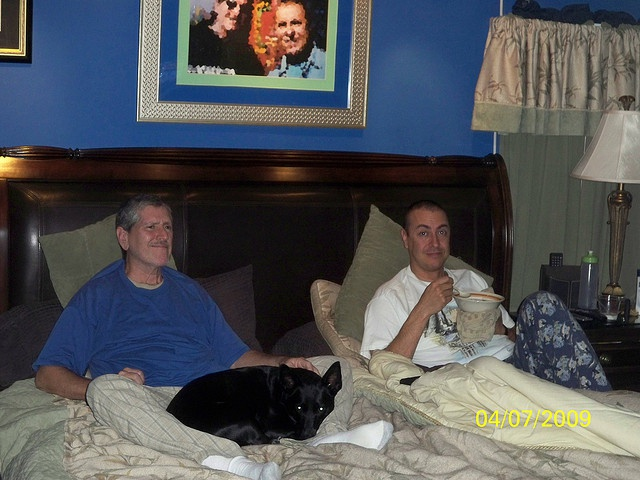Describe the objects in this image and their specific colors. I can see bed in tan, black, gray, darkgray, and navy tones, people in tan, navy, darkgray, gray, and black tones, dog in tan, black, navy, gray, and darkgray tones, bottle in tan, black, gray, and darkgreen tones, and bowl in tan, darkgray, and gray tones in this image. 